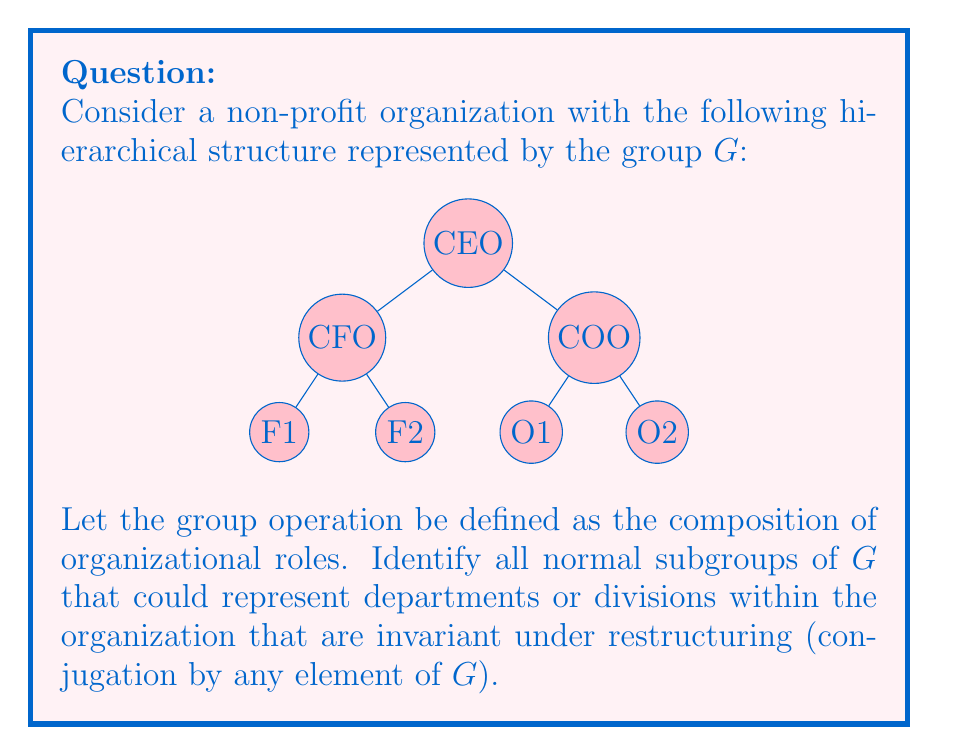Give your solution to this math problem. To solve this problem, we need to analyze the group structure and identify its normal subgroups. Let's approach this step-by-step:

1) First, let's identify the elements of the group $G$:
   $G = \{e, \text{CEO}, \text{CFO}, \text{COO}, \text{F1}, \text{F2}, \text{O1}, \text{O2}\}$
   where $e$ represents the identity element (no change in role).

2) The subgroups of $G$ will represent various departments or divisions within the organization.

3) To be a normal subgroup, a subgroup $H$ must satisfy the condition:
   $gHg^{-1} = H$ for all $g \in G$

4) The trivial subgroups $\{e\}$ and $G$ itself are always normal subgroups.

5) Let's consider the finance department subgroup:
   $H_F = \{e, \text{CFO}, \text{F1}, \text{F2}\}$
   This subgroup is normal because conjugating it by any element of $G$ will result in the same set of roles within the finance department.

6) Similarly, the operations department subgroup:
   $H_O = \{e, \text{COO}, \text{O1}, \text{O2}\}$
   is also a normal subgroup for the same reason.

7) The subgroup of all non-CEO roles:
   $H_{NC} = \{e, \text{CFO}, \text{COO}, \text{F1}, \text{F2}, \text{O1}, \text{O2}\}$
   is normal because conjugating it by any element (including the CEO) will result in the same set of non-CEO roles.

8) Other possible subgroups like $\{e, \text{F1}\}$ or $\{e, \text{O1}, \text{O2}\}$ are not normal because conjugating them by elements outside the subgroup doesn't preserve the subgroup structure.

Therefore, the normal subgroups of $G$ are $\{e\}$, $H_F$, $H_O$, $H_{NC}$, and $G$ itself.
Answer: $\{e\}$, $\{e, \text{CFO}, \text{F1}, \text{F2}\}$, $\{e, \text{COO}, \text{O1}, \text{O2}\}$, $\{e, \text{CFO}, \text{COO}, \text{F1}, \text{F2}, \text{O1}, \text{O2}\}$, $G$ 